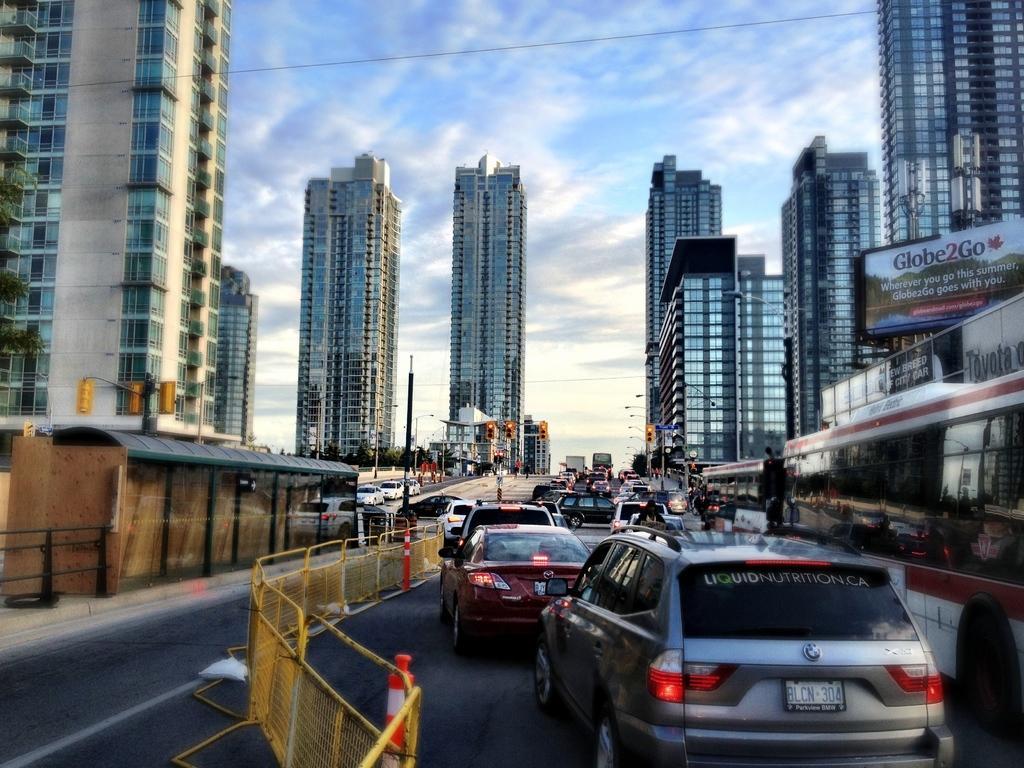Can you describe this image briefly? There is a road on which, there are vehicles which are in different colors, there are yellow color barricades which are connected with each other. On the left side, there are towers which are having glass windows and there are vehicles on the other road. On the right side, there are buildings which are having glass windows. In the background, there are hoardings and there are clouds in the blue sky. 